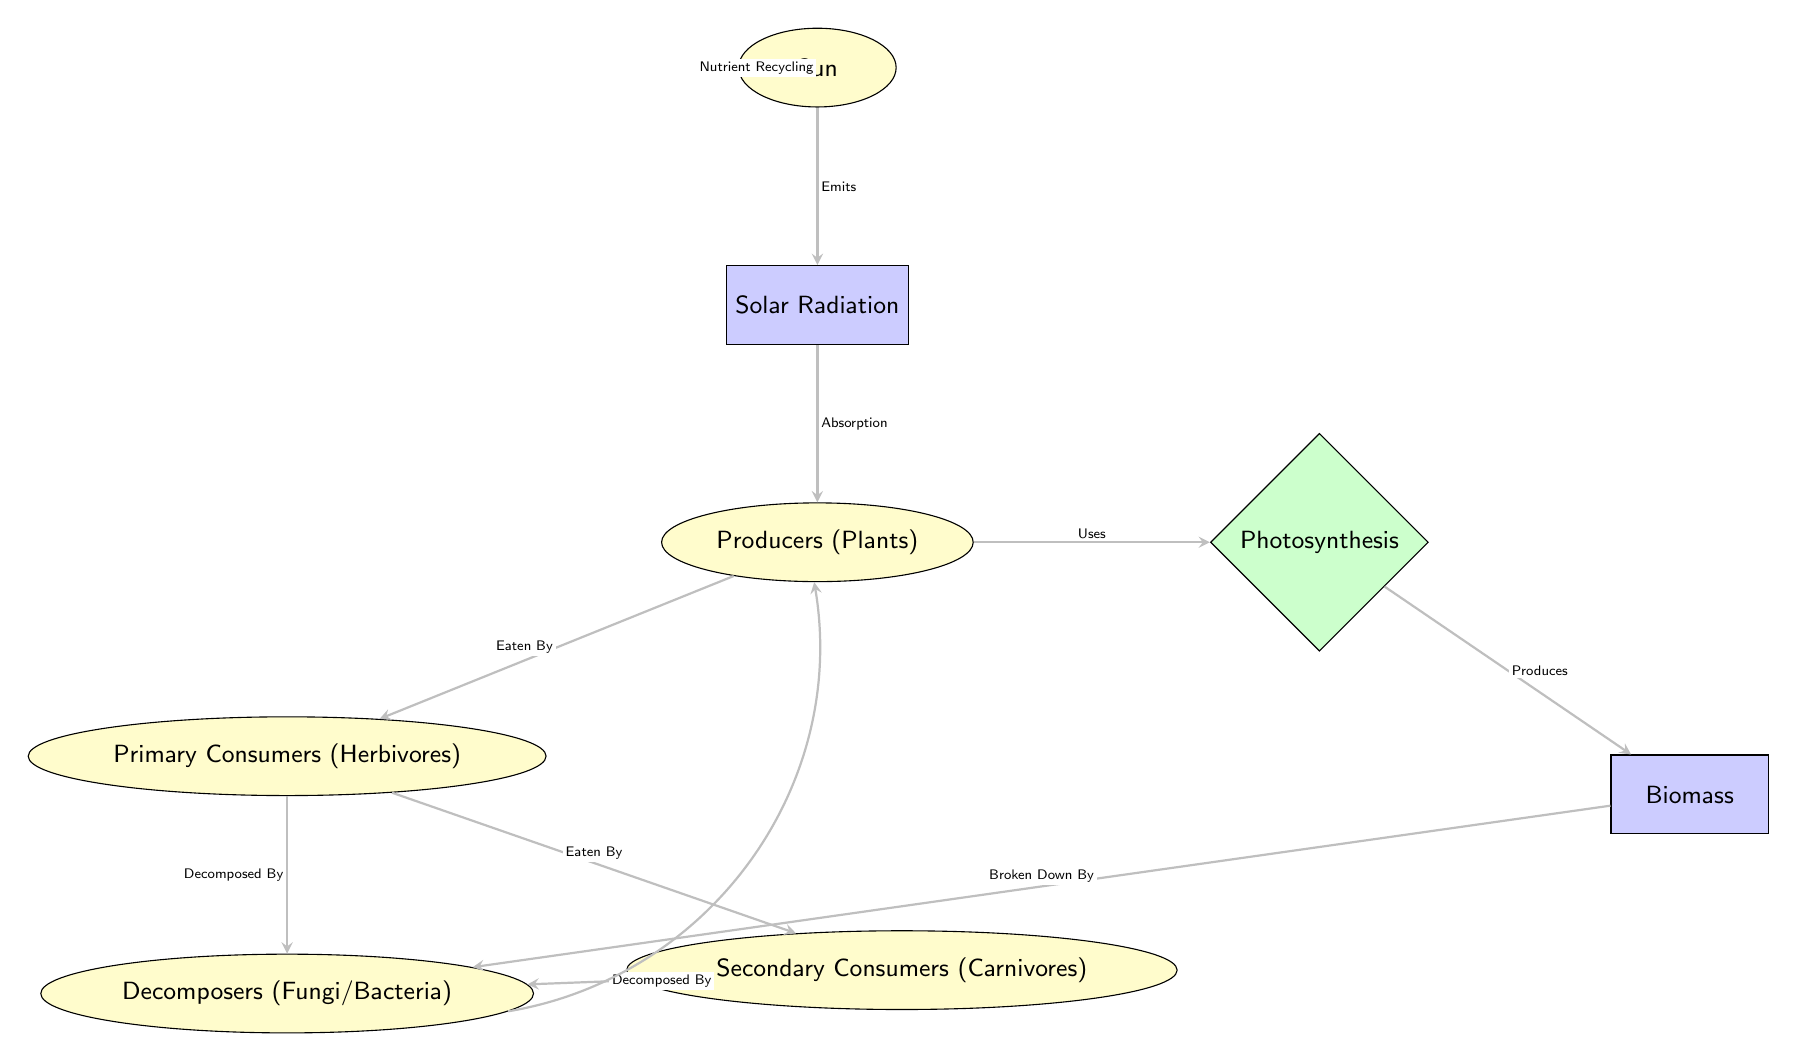What is the first node in the energy flow? The first node in the energy flow is the Sun, from which the entire process of energy conversion begins.
Answer: Sun What node receives solar radiation? The node that receives solar radiation is Producers (Plants), as it directly absorbs the energy provided by the solar radiation from the Sun.
Answer: Producers (Plants) How many types of consumers are there in the diagram? There are two types of consumers in the diagram: Primary Consumers (Herbivores) and Secondary Consumers (Carnivores), which are indicated as separate nodes.
Answer: Two What process do producers use to convert energy? The process that producers use to convert energy is Photosynthesis, which connects their energy absorption to the production of biomass.
Answer: Photosynthesis What is produced as a result of photosynthesis? The result of photosynthesis is Biomass, which is generated from the energy absorbed by producers through this process.
Answer: Biomass How are primary consumers related to decomposers? Primary consumers are related to decomposers through the relationship "Decomposed By," indicating that when primary consumers die or excrete waste, they contribute organic matter for decomposers to break down.
Answer: Decomposed By What happens to biomass according to the diagram? According to the diagram, biomass is broken down by decomposers, signifying the flow of energy and nutrients back into the ecosystem after the biomass is utilized.
Answer: Broken Down By What connection exists between decomposers and producers? The connection that exists between decomposers and producers is Nutrient Recycling, showing a cyclical relationship where decomposers return nutrients to the soil for producers to use again.
Answer: Nutrient Recycling Which arrows indicate the flow of energy? The arrows indicating the flow of energy include those from Sun to Solar Radiation, Solar Radiation to Producers, Producers to Photosynthesis, and Photosynthesis to Biomass, depicting the conversion and transfer of solar energy through the ecosystem.
Answer: Energy Flow Arrows 